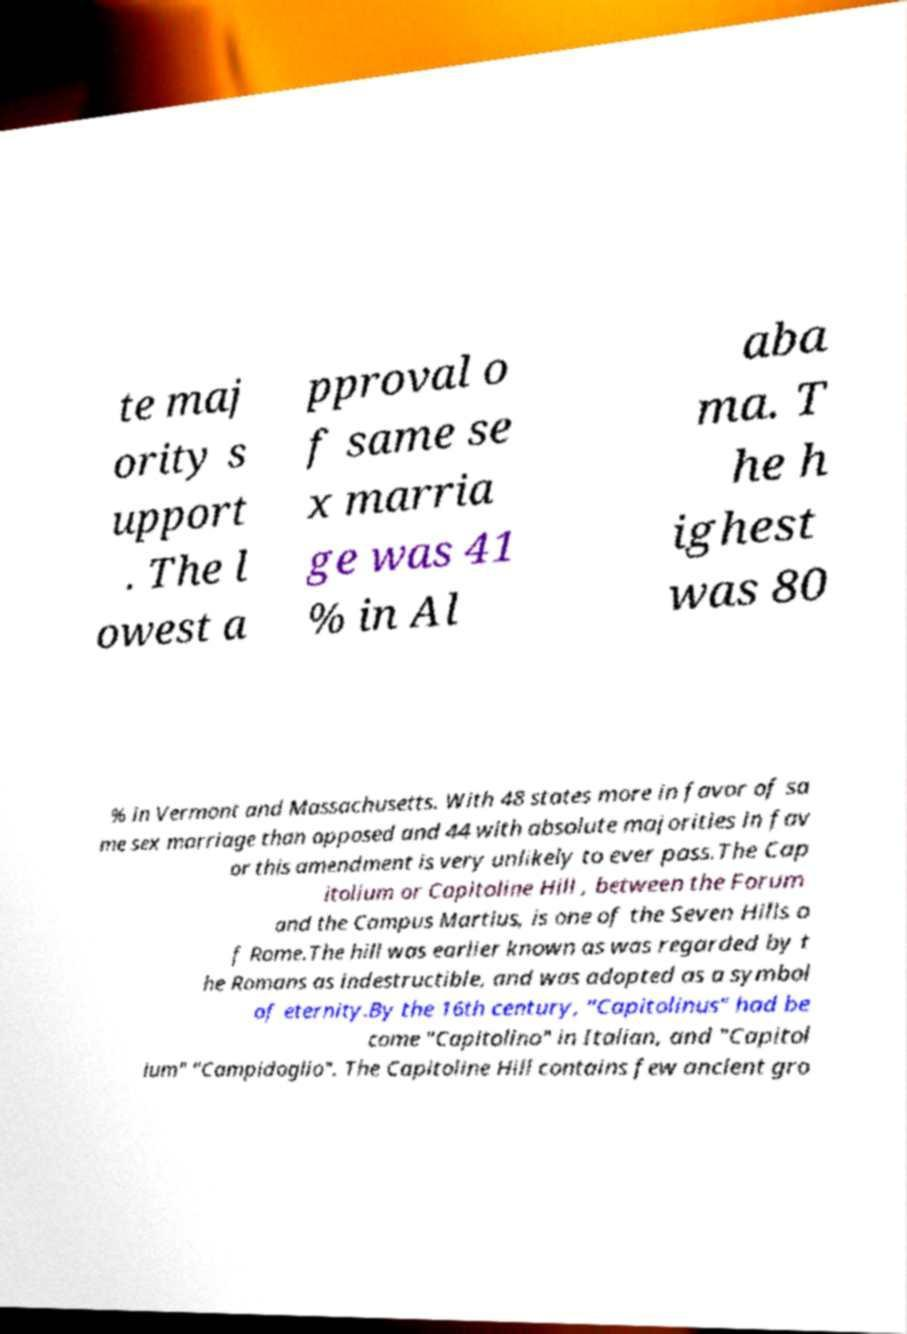Could you assist in decoding the text presented in this image and type it out clearly? te maj ority s upport . The l owest a pproval o f same se x marria ge was 41 % in Al aba ma. T he h ighest was 80 % in Vermont and Massachusetts. With 48 states more in favor of sa me sex marriage than opposed and 44 with absolute majorities in fav or this amendment is very unlikely to ever pass.The Cap itolium or Capitoline Hill , between the Forum and the Campus Martius, is one of the Seven Hills o f Rome.The hill was earlier known as was regarded by t he Romans as indestructible, and was adopted as a symbol of eternity.By the 16th century, "Capitolinus" had be come "Capitolino" in Italian, and "Capitol ium" "Campidoglio". The Capitoline Hill contains few ancient gro 